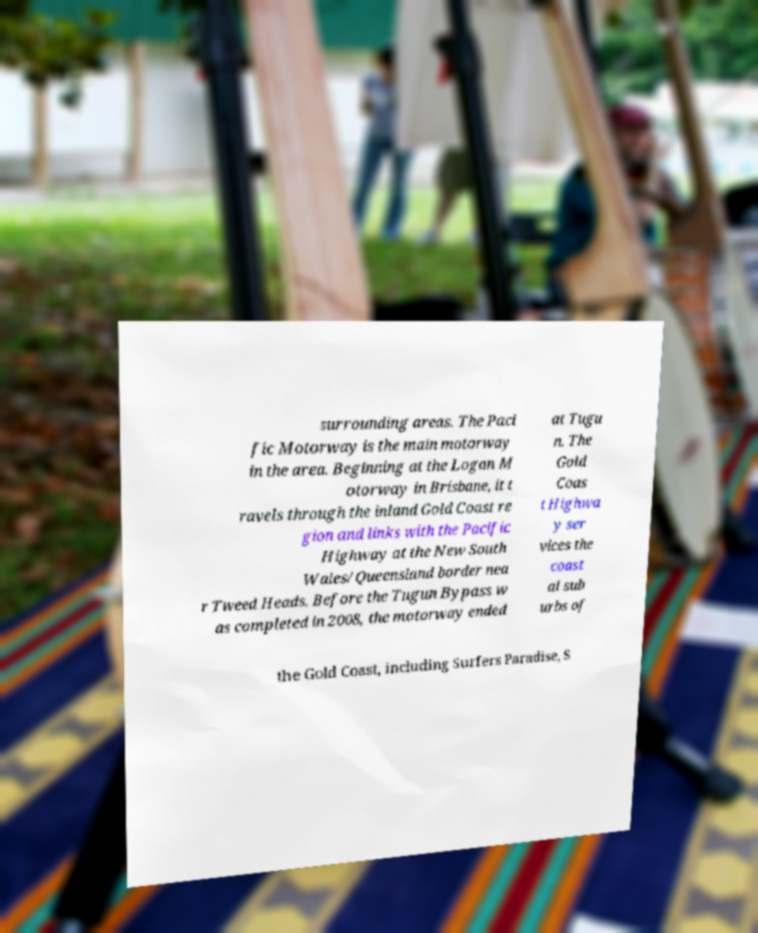Can you accurately transcribe the text from the provided image for me? surrounding areas. The Paci fic Motorway is the main motorway in the area. Beginning at the Logan M otorway in Brisbane, it t ravels through the inland Gold Coast re gion and links with the Pacific Highway at the New South Wales/Queensland border nea r Tweed Heads. Before the Tugun Bypass w as completed in 2008, the motorway ended at Tugu n. The Gold Coas t Highwa y ser vices the coast al sub urbs of the Gold Coast, including Surfers Paradise, S 